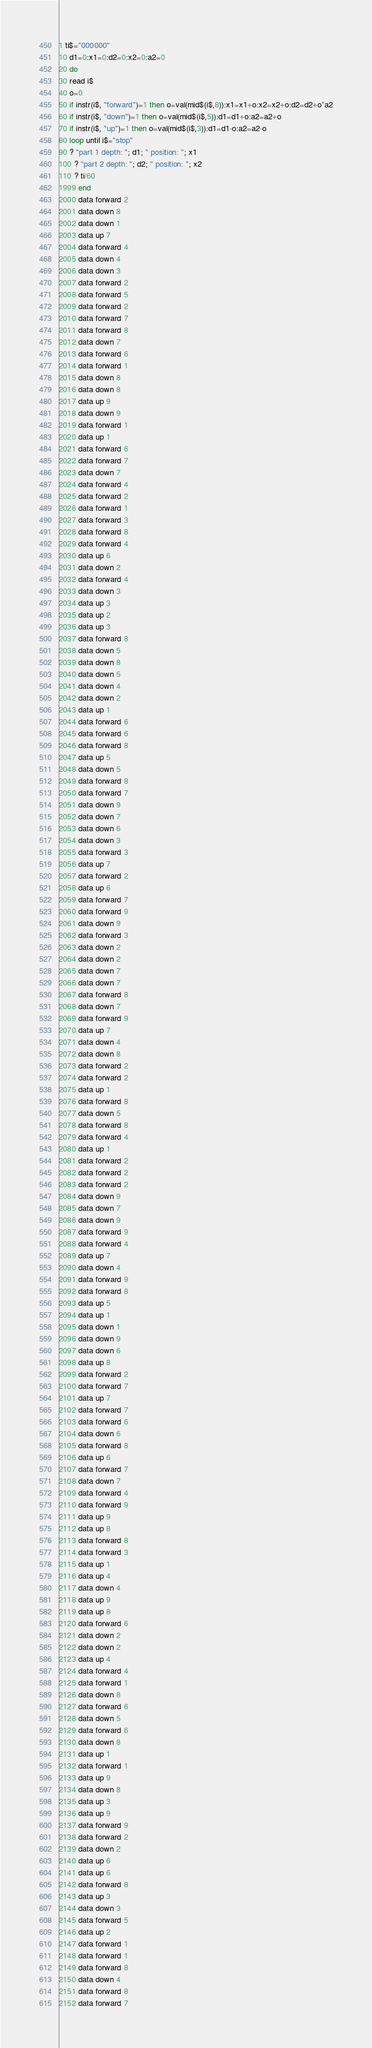Convert code to text. <code><loc_0><loc_0><loc_500><loc_500><_VisualBasic_>1 ti$="000000"
10 d1=0:x1=0:d2=0:x2=0:a2=0
20 do
30 read i$
40 o=0
50 if instr(i$, "forward")=1 then o=val(mid$(i$,8)):x1=x1+o:x2=x2+o:d2=d2+o*a2
60 if instr(i$, "down")=1 then o=val(mid$(i$,5)):d1=d1+o:a2=a2+o
70 if instr(i$, "up")=1 then o=val(mid$(i$,3)):d1=d1-o:a2=a2-o
80 loop until i$="stop"
90 ? "part 1 depth: "; d1; " position: "; x1
100 ? "part 2 depth: "; d2; " position: "; x2
110 ? ti/60
1999 end
2000 data forward 2
2001 data down 8
2002 data down 1
2003 data up 7
2004 data forward 4
2005 data down 4
2006 data down 3
2007 data forward 2
2008 data forward 5
2009 data forward 2
2010 data forward 7
2011 data forward 8
2012 data down 7
2013 data forward 6
2014 data forward 1
2015 data down 8
2016 data down 8
2017 data up 9
2018 data down 9
2019 data forward 1
2020 data up 1
2021 data forward 6
2022 data forward 7
2023 data down 7
2024 data forward 4
2025 data forward 2
2026 data forward 1
2027 data forward 3
2028 data forward 8
2029 data forward 4
2030 data up 6
2031 data down 2
2032 data forward 4
2033 data down 3
2034 data up 3
2035 data up 2
2036 data up 3
2037 data forward 8
2038 data down 5
2039 data down 8
2040 data down 5
2041 data down 4
2042 data down 2
2043 data up 1
2044 data forward 6
2045 data forward 6
2046 data forward 8
2047 data up 5
2048 data down 5
2049 data forward 8
2050 data forward 7
2051 data down 9
2052 data down 7
2053 data down 6
2054 data down 3
2055 data forward 3
2056 data up 7
2057 data forward 2
2058 data up 6
2059 data forward 7
2060 data forward 9
2061 data down 9
2062 data forward 3
2063 data down 2
2064 data down 2
2065 data down 7
2066 data down 7
2067 data forward 8
2068 data down 7
2069 data forward 9
2070 data up 7
2071 data down 4
2072 data down 8
2073 data forward 2
2074 data forward 2
2075 data up 1
2076 data forward 8
2077 data down 5
2078 data forward 8
2079 data forward 4
2080 data up 1
2081 data forward 2
2082 data forward 2
2083 data forward 2
2084 data down 9
2085 data down 7
2086 data down 9
2087 data forward 9
2088 data forward 4
2089 data up 7
2090 data down 4
2091 data forward 9
2092 data forward 8
2093 data up 5
2094 data up 1
2095 data down 1
2096 data down 9
2097 data down 6
2098 data up 8
2099 data forward 2
2100 data forward 7
2101 data up 7
2102 data forward 7
2103 data forward 6
2104 data down 6
2105 data forward 8
2106 data up 6
2107 data forward 7
2108 data down 7
2109 data forward 4
2110 data forward 9
2111 data up 9
2112 data up 8
2113 data forward 8
2114 data forward 3
2115 data up 1
2116 data up 4
2117 data down 4
2118 data up 9
2119 data up 8
2120 data forward 6
2121 data down 2
2122 data down 2
2123 data up 4
2124 data forward 4
2125 data forward 1
2126 data down 8
2127 data forward 6
2128 data down 5
2129 data forward 6
2130 data down 8
2131 data up 1
2132 data forward 1
2133 data up 9
2134 data down 8
2135 data up 3
2136 data up 9
2137 data forward 9
2138 data forward 2
2139 data down 2
2140 data up 6
2141 data up 6
2142 data forward 8
2143 data up 3
2144 data down 3
2145 data forward 5
2146 data up 2
2147 data forward 1
2148 data forward 1
2149 data forward 8
2150 data down 4
2151 data forward 8
2152 data forward 7</code> 